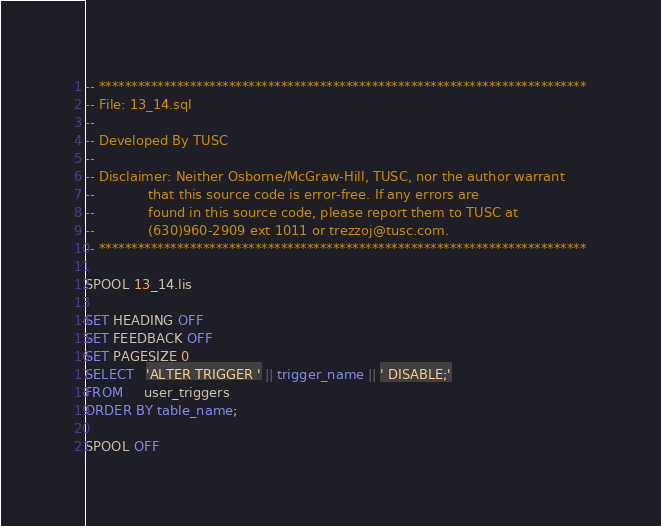<code> <loc_0><loc_0><loc_500><loc_500><_SQL_>-- ***************************************************************************
-- File: 13_14.sql
--
-- Developed By TUSC
--
-- Disclaimer: Neither Osborne/McGraw-Hill, TUSC, nor the author warrant
--             that this source code is error-free. If any errors are
--             found in this source code, please report them to TUSC at
--             (630)960-2909 ext 1011 or trezzoj@tusc.com.
-- ***************************************************************************

SPOOL 13_14.lis

SET HEADING OFF
SET FEEDBACK OFF
SET PAGESIZE 0
SELECT   'ALTER TRIGGER ' || trigger_name || ' DISABLE;'
FROM     user_triggers
ORDER BY table_name;

SPOOL OFF
</code> 